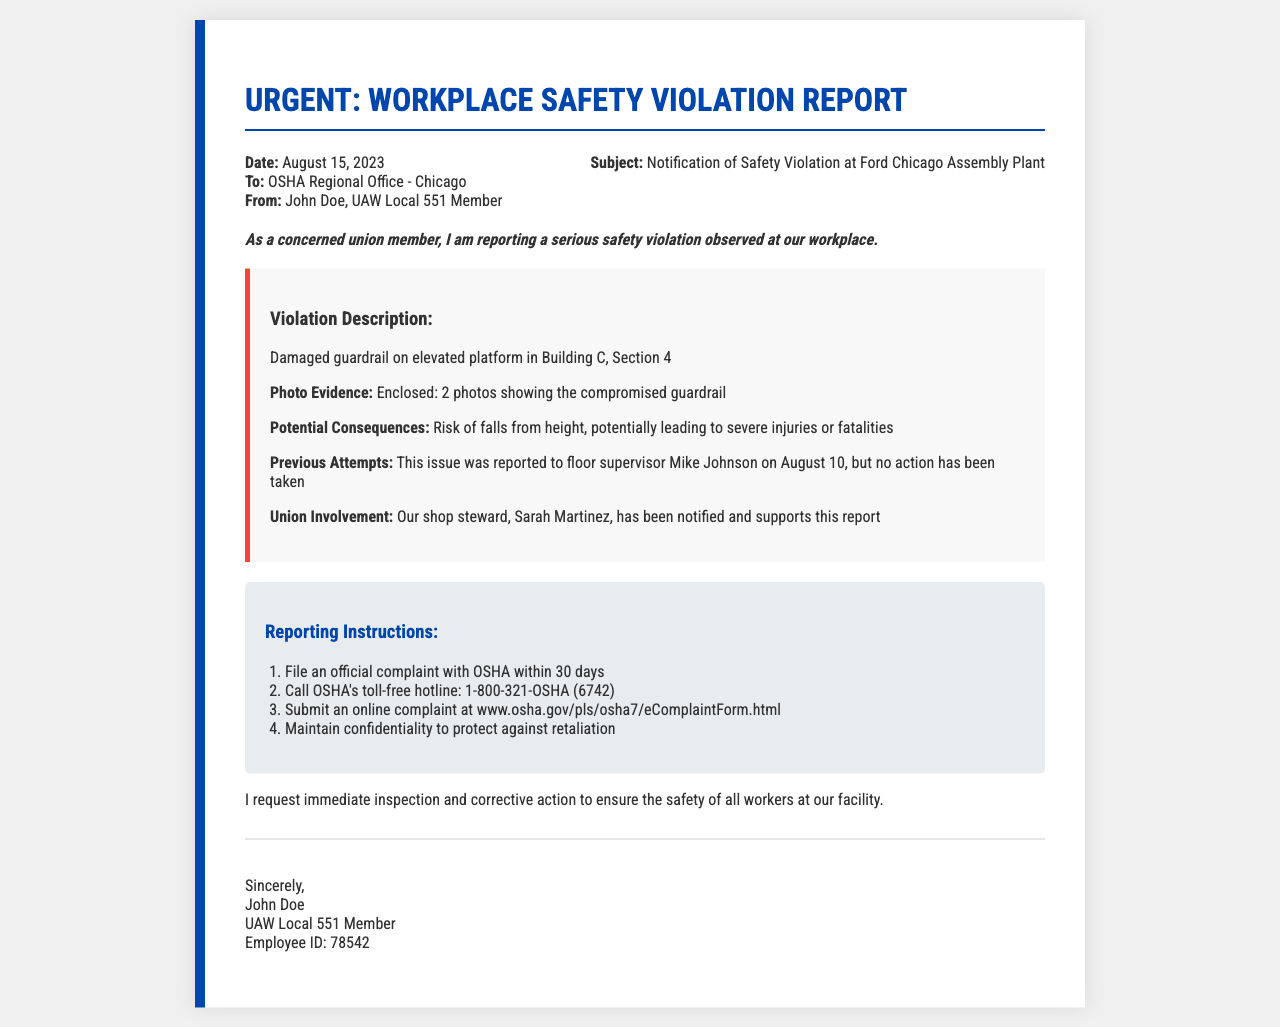What is the date of the report? The date of the report is the first piece of information listed in the document.
Answer: August 15, 2023 Who is the sender of the report? The sender is specified right below the "From:" label in the header information.
Answer: John Doe, UAW Local 551 Member What is the violation described in the document? The violation description is detailed in its own section, highlighting the specific issue in the workplace.
Answer: Damaged guardrail on elevated platform in Building C, Section 4 What were the previous attempts to report the violation? Previous attempts to report the violation are mentioned under "Previous Attempts" in the violation details section.
Answer: Reported to floor supervisor Mike Johnson on August 10 What is the first reporting instruction listed? The first instruction is noted under the "Reporting Instructions" section, outlining the steps to take.
Answer: File an official complaint with OSHA within 30 days What risk is associated with the reported violation? The potential consequences mentioned alongside the violation describe the risks involved.
Answer: Risk of falls from height Who supports the report mentioned in the document? Union involvement is highlighted, stating specific details about support from union representatives.
Answer: Sarah Martinez What should workers maintain to protect against retaliation? This aspect is specifically emphasized in the reporting instructions.
Answer: Confidentiality 